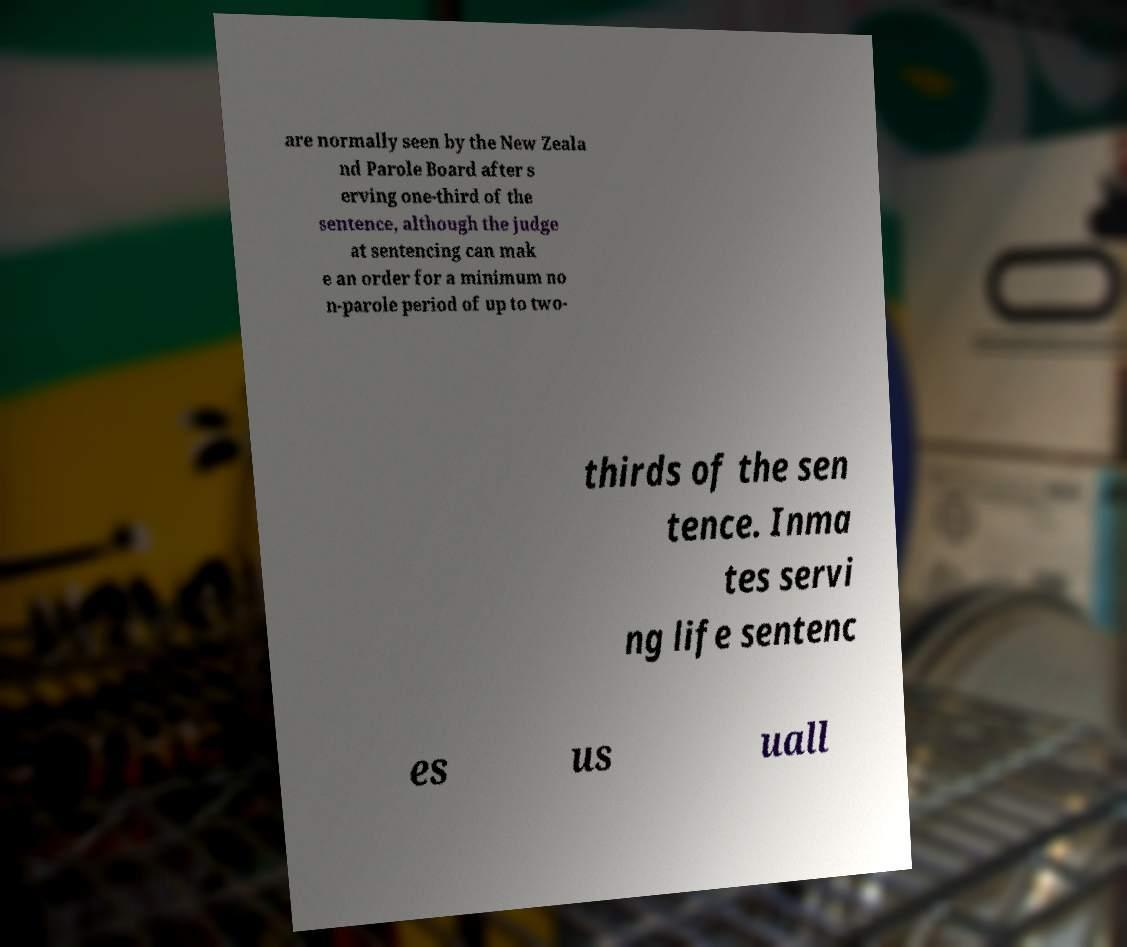For documentation purposes, I need the text within this image transcribed. Could you provide that? are normally seen by the New Zeala nd Parole Board after s erving one-third of the sentence, although the judge at sentencing can mak e an order for a minimum no n-parole period of up to two- thirds of the sen tence. Inma tes servi ng life sentenc es us uall 